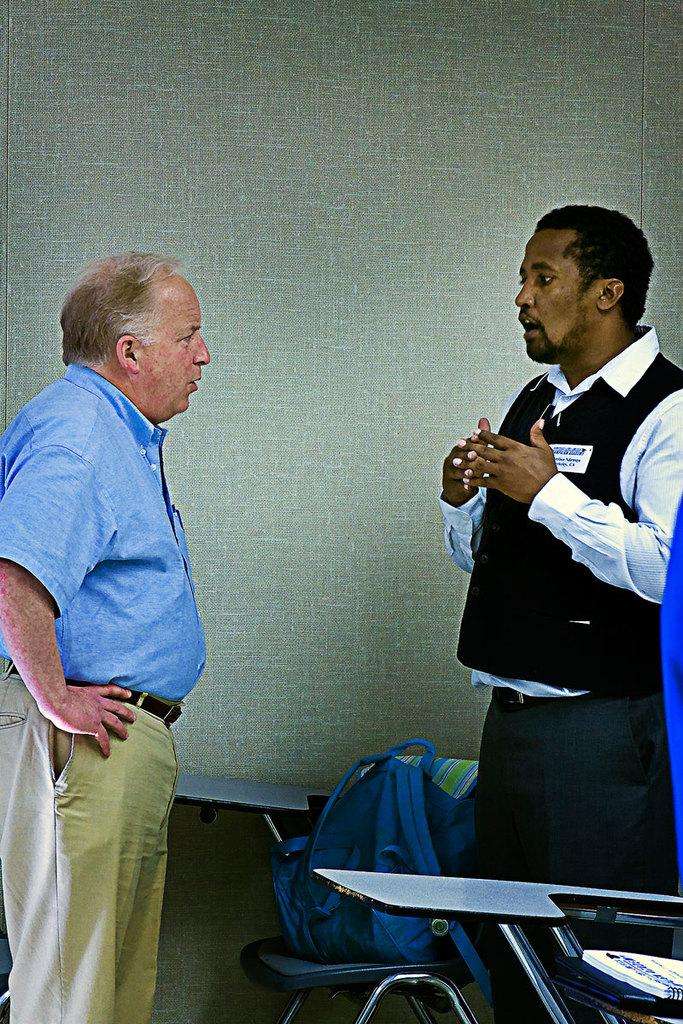How many people are in the image? There are two persons standing in the center of the image. What is placed between the two persons? There is a chair, a bag, a book, and a few other objects between the two persons. What can be seen in the background of the image? There is a wall in the background of the image. How many toes can be seen on the persons in the image? There is no information about the toes of the persons in the image, so it cannot be determined. 